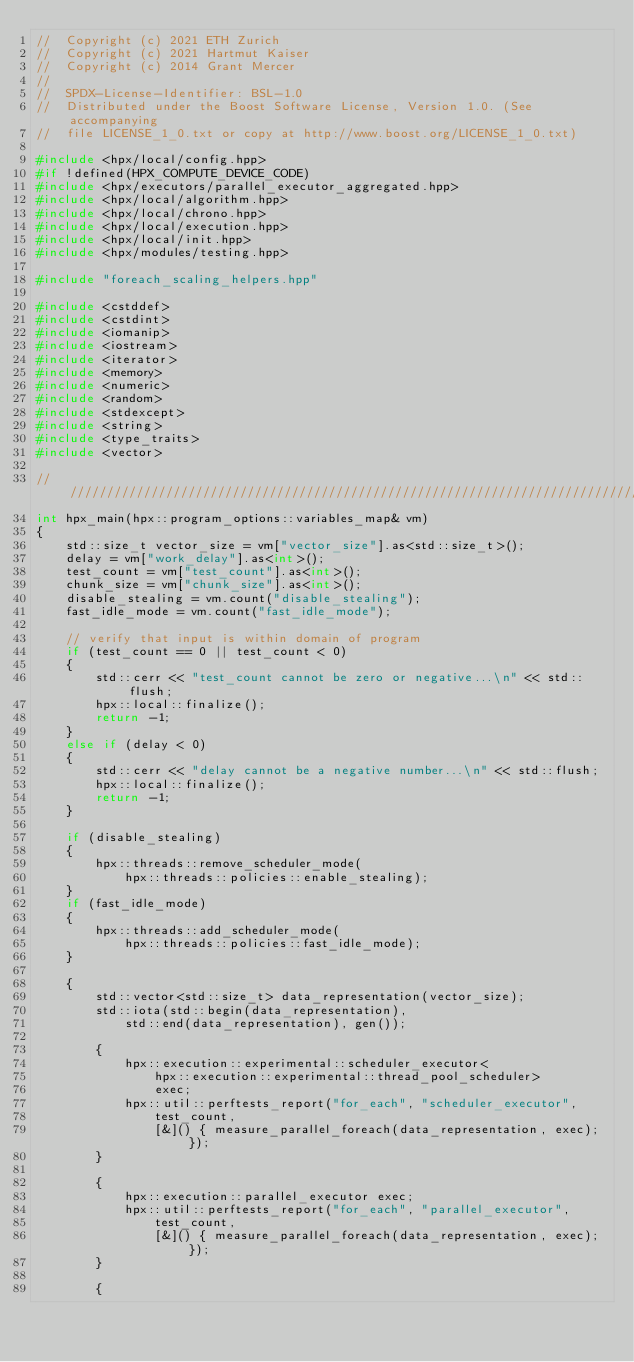<code> <loc_0><loc_0><loc_500><loc_500><_C++_>//  Copyright (c) 2021 ETH Zurich
//  Copyright (c) 2021 Hartmut Kaiser
//  Copyright (c) 2014 Grant Mercer
//
//  SPDX-License-Identifier: BSL-1.0
//  Distributed under the Boost Software License, Version 1.0. (See accompanying
//  file LICENSE_1_0.txt or copy at http://www.boost.org/LICENSE_1_0.txt)

#include <hpx/local/config.hpp>
#if !defined(HPX_COMPUTE_DEVICE_CODE)
#include <hpx/executors/parallel_executor_aggregated.hpp>
#include <hpx/local/algorithm.hpp>
#include <hpx/local/chrono.hpp>
#include <hpx/local/execution.hpp>
#include <hpx/local/init.hpp>
#include <hpx/modules/testing.hpp>

#include "foreach_scaling_helpers.hpp"

#include <cstddef>
#include <cstdint>
#include <iomanip>
#include <iostream>
#include <iterator>
#include <memory>
#include <numeric>
#include <random>
#include <stdexcept>
#include <string>
#include <type_traits>
#include <vector>

///////////////////////////////////////////////////////////////////////////////
int hpx_main(hpx::program_options::variables_map& vm)
{
    std::size_t vector_size = vm["vector_size"].as<std::size_t>();
    delay = vm["work_delay"].as<int>();
    test_count = vm["test_count"].as<int>();
    chunk_size = vm["chunk_size"].as<int>();
    disable_stealing = vm.count("disable_stealing");
    fast_idle_mode = vm.count("fast_idle_mode");

    // verify that input is within domain of program
    if (test_count == 0 || test_count < 0)
    {
        std::cerr << "test_count cannot be zero or negative...\n" << std::flush;
        hpx::local::finalize();
        return -1;
    }
    else if (delay < 0)
    {
        std::cerr << "delay cannot be a negative number...\n" << std::flush;
        hpx::local::finalize();
        return -1;
    }

    if (disable_stealing)
    {
        hpx::threads::remove_scheduler_mode(
            hpx::threads::policies::enable_stealing);
    }
    if (fast_idle_mode)
    {
        hpx::threads::add_scheduler_mode(
            hpx::threads::policies::fast_idle_mode);
    }

    {
        std::vector<std::size_t> data_representation(vector_size);
        std::iota(std::begin(data_representation),
            std::end(data_representation), gen());

        {
            hpx::execution::experimental::scheduler_executor<
                hpx::execution::experimental::thread_pool_scheduler>
                exec;
            hpx::util::perftests_report("for_each", "scheduler_executor",
                test_count,
                [&]() { measure_parallel_foreach(data_representation, exec); });
        }

        {
            hpx::execution::parallel_executor exec;
            hpx::util::perftests_report("for_each", "parallel_executor",
                test_count,
                [&]() { measure_parallel_foreach(data_representation, exec); });
        }

        {</code> 